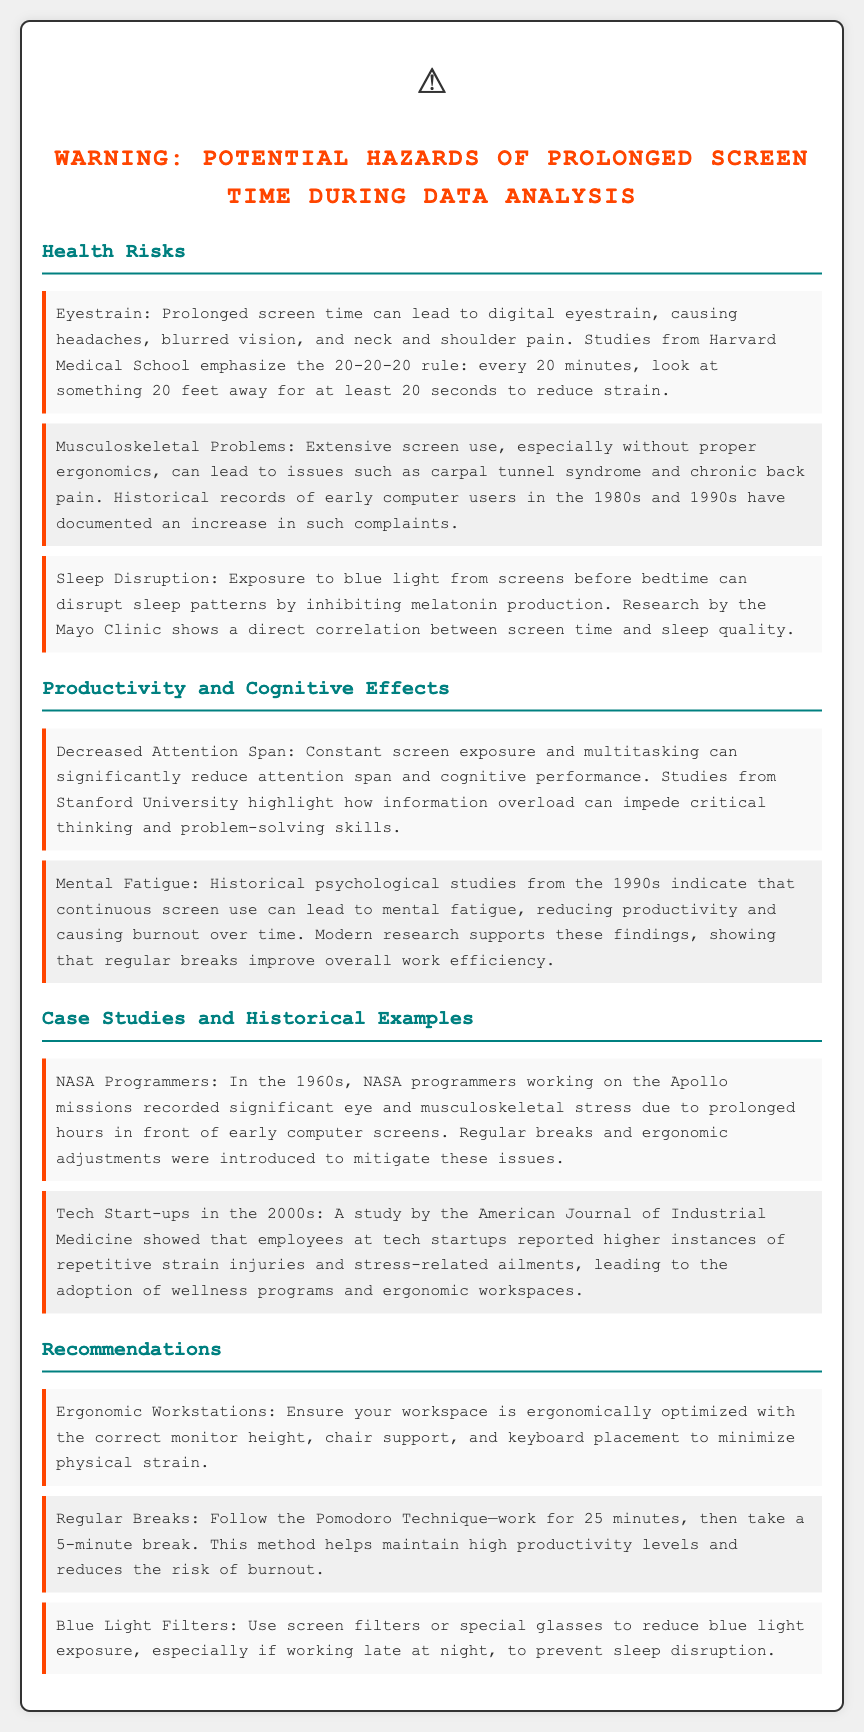What is the main health risk associated with prolonged screen time? The document highlights eyestrain as a primary health risk due to prolonged screen time.
Answer: eyestrain What does the 20-20-20 rule recommend? The 20-20-20 rule suggests looking at something 20 feet away for 20 seconds every 20 minutes to reduce digital eyestrain.
Answer: look at something 20 feet away for 20 seconds Which institute has conducted research linking screen time and sleep quality? The Mayo Clinic is cited for research showing a direct correlation between screen time and sleep quality.
Answer: Mayo Clinic What productivity effect is caused by constant screen exposure? The document states that decreased attention span results from constant screen exposure and multitasking.
Answer: decreased attention span In what decade did NASA programmers experience stress from prolonged screen use? NASA programmers recorded stress from prolonged screen use during the 1960s.
Answer: 1960s What ergonomic recommendation is made for workstations? The document recommends ensuring workstations are ergonomically optimized to minimize physical strain.
Answer: ergonomically optimized How long should breaks be according to the Pomodoro Technique? The Pomodoro Technique suggests taking a 5-minute break after working for 25 minutes.
Answer: 5 minutes What were tech startups in the 2000s reported to have higher instances of? Employees at tech startups in the 2000s reported higher instances of repetitive strain injuries.
Answer: repetitive strain injuries Which method is suggested to reduce blue light exposure? The document suggests using screen filters or special glasses to reduce blue light exposure.
Answer: screen filters or special glasses 